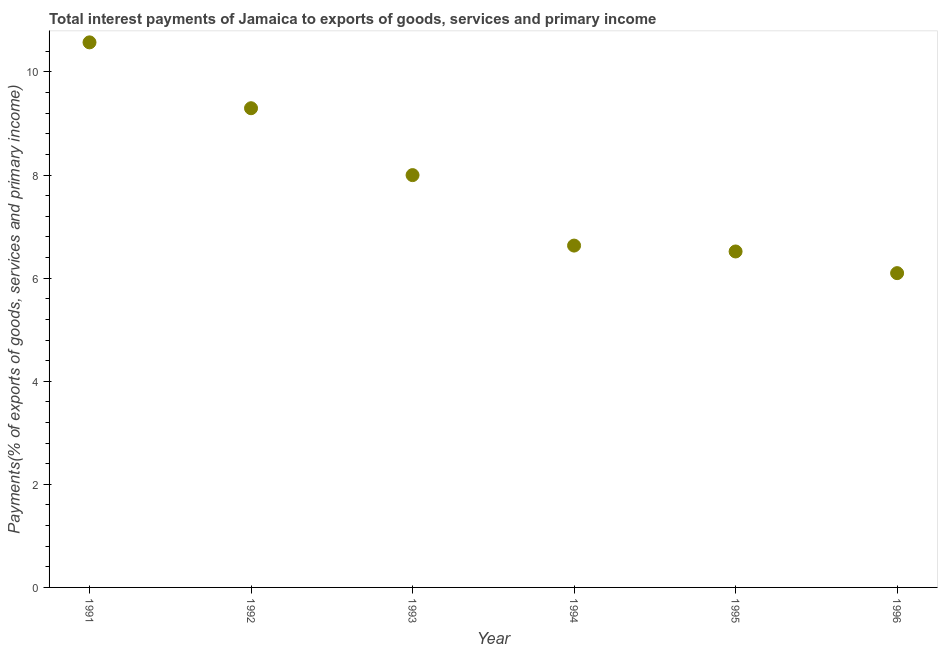What is the total interest payments on external debt in 1992?
Provide a succinct answer. 9.3. Across all years, what is the maximum total interest payments on external debt?
Your answer should be very brief. 10.57. Across all years, what is the minimum total interest payments on external debt?
Provide a succinct answer. 6.1. What is the sum of the total interest payments on external debt?
Ensure brevity in your answer.  47.12. What is the difference between the total interest payments on external debt in 1992 and 1995?
Give a very brief answer. 2.78. What is the average total interest payments on external debt per year?
Keep it short and to the point. 7.85. What is the median total interest payments on external debt?
Offer a very short reply. 7.32. In how many years, is the total interest payments on external debt greater than 6 %?
Your answer should be very brief. 6. Do a majority of the years between 1996 and 1994 (inclusive) have total interest payments on external debt greater than 1.6 %?
Provide a succinct answer. No. What is the ratio of the total interest payments on external debt in 1992 to that in 1995?
Provide a short and direct response. 1.43. Is the total interest payments on external debt in 1992 less than that in 1995?
Ensure brevity in your answer.  No. What is the difference between the highest and the second highest total interest payments on external debt?
Provide a succinct answer. 1.28. Is the sum of the total interest payments on external debt in 1993 and 1996 greater than the maximum total interest payments on external debt across all years?
Make the answer very short. Yes. What is the difference between the highest and the lowest total interest payments on external debt?
Ensure brevity in your answer.  4.48. Does the total interest payments on external debt monotonically increase over the years?
Provide a succinct answer. No. What is the difference between two consecutive major ticks on the Y-axis?
Offer a terse response. 2. What is the title of the graph?
Give a very brief answer. Total interest payments of Jamaica to exports of goods, services and primary income. What is the label or title of the X-axis?
Your answer should be very brief. Year. What is the label or title of the Y-axis?
Make the answer very short. Payments(% of exports of goods, services and primary income). What is the Payments(% of exports of goods, services and primary income) in 1991?
Your response must be concise. 10.57. What is the Payments(% of exports of goods, services and primary income) in 1992?
Your answer should be very brief. 9.3. What is the Payments(% of exports of goods, services and primary income) in 1993?
Keep it short and to the point. 8. What is the Payments(% of exports of goods, services and primary income) in 1994?
Keep it short and to the point. 6.63. What is the Payments(% of exports of goods, services and primary income) in 1995?
Offer a very short reply. 6.52. What is the Payments(% of exports of goods, services and primary income) in 1996?
Offer a terse response. 6.1. What is the difference between the Payments(% of exports of goods, services and primary income) in 1991 and 1992?
Your response must be concise. 1.28. What is the difference between the Payments(% of exports of goods, services and primary income) in 1991 and 1993?
Your answer should be very brief. 2.58. What is the difference between the Payments(% of exports of goods, services and primary income) in 1991 and 1994?
Provide a succinct answer. 3.94. What is the difference between the Payments(% of exports of goods, services and primary income) in 1991 and 1995?
Provide a short and direct response. 4.06. What is the difference between the Payments(% of exports of goods, services and primary income) in 1991 and 1996?
Provide a short and direct response. 4.48. What is the difference between the Payments(% of exports of goods, services and primary income) in 1992 and 1993?
Provide a short and direct response. 1.3. What is the difference between the Payments(% of exports of goods, services and primary income) in 1992 and 1994?
Keep it short and to the point. 2.66. What is the difference between the Payments(% of exports of goods, services and primary income) in 1992 and 1995?
Keep it short and to the point. 2.78. What is the difference between the Payments(% of exports of goods, services and primary income) in 1992 and 1996?
Provide a short and direct response. 3.2. What is the difference between the Payments(% of exports of goods, services and primary income) in 1993 and 1994?
Ensure brevity in your answer.  1.37. What is the difference between the Payments(% of exports of goods, services and primary income) in 1993 and 1995?
Make the answer very short. 1.48. What is the difference between the Payments(% of exports of goods, services and primary income) in 1993 and 1996?
Offer a terse response. 1.9. What is the difference between the Payments(% of exports of goods, services and primary income) in 1994 and 1995?
Offer a very short reply. 0.11. What is the difference between the Payments(% of exports of goods, services and primary income) in 1994 and 1996?
Provide a succinct answer. 0.53. What is the difference between the Payments(% of exports of goods, services and primary income) in 1995 and 1996?
Offer a terse response. 0.42. What is the ratio of the Payments(% of exports of goods, services and primary income) in 1991 to that in 1992?
Your answer should be very brief. 1.14. What is the ratio of the Payments(% of exports of goods, services and primary income) in 1991 to that in 1993?
Keep it short and to the point. 1.32. What is the ratio of the Payments(% of exports of goods, services and primary income) in 1991 to that in 1994?
Your response must be concise. 1.59. What is the ratio of the Payments(% of exports of goods, services and primary income) in 1991 to that in 1995?
Your answer should be very brief. 1.62. What is the ratio of the Payments(% of exports of goods, services and primary income) in 1991 to that in 1996?
Provide a short and direct response. 1.73. What is the ratio of the Payments(% of exports of goods, services and primary income) in 1992 to that in 1993?
Offer a terse response. 1.16. What is the ratio of the Payments(% of exports of goods, services and primary income) in 1992 to that in 1994?
Ensure brevity in your answer.  1.4. What is the ratio of the Payments(% of exports of goods, services and primary income) in 1992 to that in 1995?
Offer a terse response. 1.43. What is the ratio of the Payments(% of exports of goods, services and primary income) in 1992 to that in 1996?
Make the answer very short. 1.52. What is the ratio of the Payments(% of exports of goods, services and primary income) in 1993 to that in 1994?
Ensure brevity in your answer.  1.21. What is the ratio of the Payments(% of exports of goods, services and primary income) in 1993 to that in 1995?
Offer a very short reply. 1.23. What is the ratio of the Payments(% of exports of goods, services and primary income) in 1993 to that in 1996?
Make the answer very short. 1.31. What is the ratio of the Payments(% of exports of goods, services and primary income) in 1994 to that in 1996?
Provide a short and direct response. 1.09. What is the ratio of the Payments(% of exports of goods, services and primary income) in 1995 to that in 1996?
Keep it short and to the point. 1.07. 